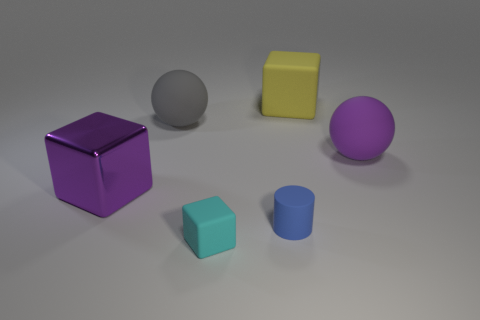What kind of lighting setup is used to illuminate the objects in the image? The objects in the image appear to be illuminated by a soft, diffused light source, given the soft shadows and gentle highlights. This type of lighting could be achieved with a larger light source, possibly through a softbox or natural light diffused through a window. 